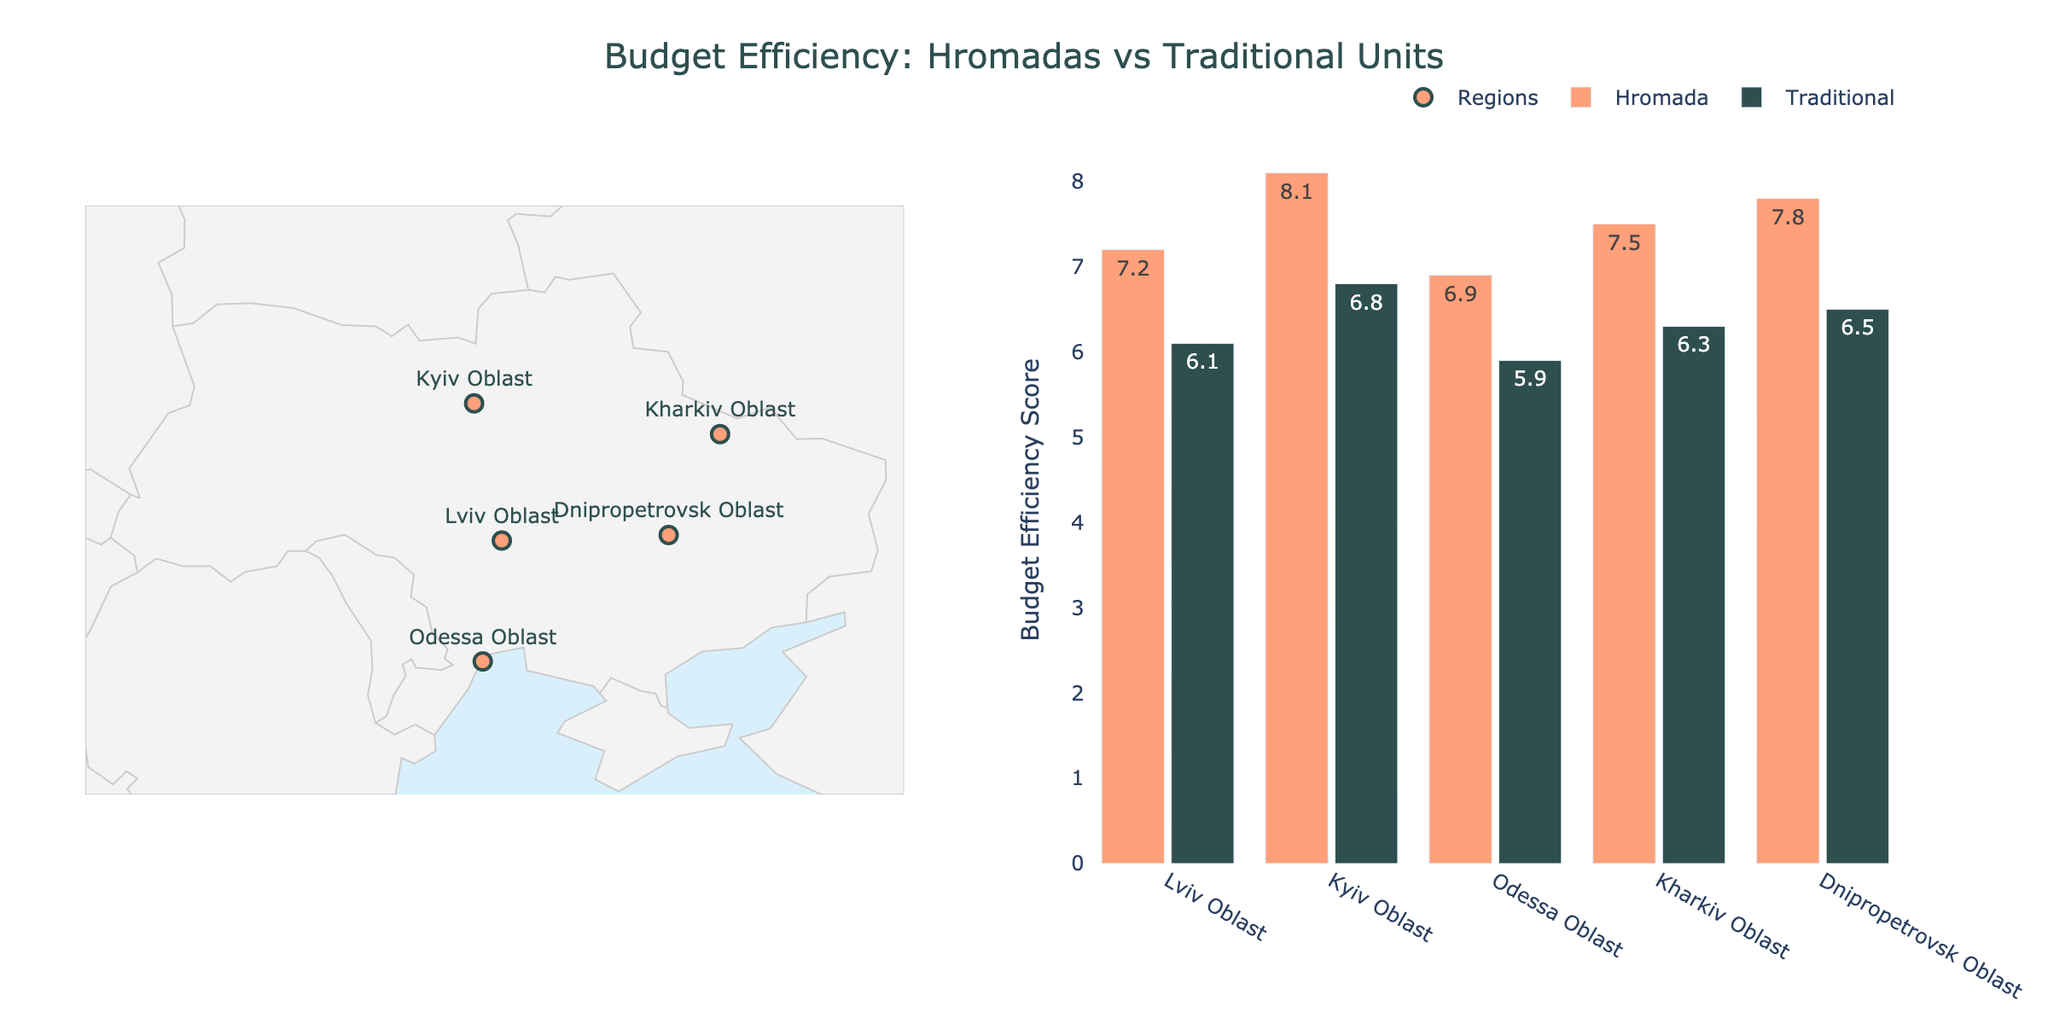Which region has the highest budget efficiency score for Hromadas? Look at the Budget Efficiency Score on the bar chart for Hromadas in each region. The highest score is 8.1 in Kyiv Oblast.
Answer: Kyiv Oblast How many regions are displayed on the map? Count the unique regions marked on the geographic scatter plot. There are 5 unique regions.
Answer: 5 Which type of administrative unit implements more projects on average across the regions? Add up the total number of projects implemented by Hromada: 42 + 38 + 36 + 40 + 41 = 197. Add up the total number of projects implemented by Traditional units: 35 + 31 + 29 + 33 + 34 = 162. Divide by the number of regions for each type (5 each). The average for Hromada is 197/5 = 39.4, and the average for Traditional is 162/5 = 32.4. Therefore, Hromada implements more projects on average.
Answer: Hromada In which region is the traditional administrative unit more efficient than the Hromada? Compare the Budget Efficiency Score of Hromada and Traditional units for each region. Traditional units are never more efficient than Hromadas in any region.
Answer: None What is the difference in budget efficiency score between Hromadas and Traditional units in Lviv Oblast? In Lviv Oblast, the budget efficiency score for Hromada is 7.2 and for Traditional units is 6.1. The difference is 7.2 - 6.1 = 1.1.
Answer: 1.1 Which region has the smallest difference in budget efficiency score between Hromadas and Traditional units? Calculate the differences in each region: Lviv Oblast (7.2 - 6.1 = 1.1), Kyiv Oblast (8.1 - 6.8 = 1.3), Odessa Oblast (6.9 - 5.9 = 1.0), Kharkiv Oblast (7.5 - 6.3 = 1.2), Dnipropetrovsk Oblast (7.8 - 6.5 = 1.3). Odessa Oblast has the smallest difference, which is 1.0.
Answer: Odessa Oblast What can be inferred about the geographical distribution of the regions with higher budget efficiency scores for Hromadas? Look at the scatter plot on the geographic map and compare the positions. Kyiv Oblast in the north-central part has the highest score of 8.1; otherwise, no clear north-south or east-west pattern.
Answer: North-central Which type of unit shows a more consistent budget efficiency score across all regions? Compare the variation in budget efficiency scores for Hromadas and Traditional units. Hromada scores range from 6.9 to 8.1 (1.2 range), while Traditional units range from 5.9 to 6.8 (0.9 range). Traditional shows more consistency.
Answer: Traditional units 